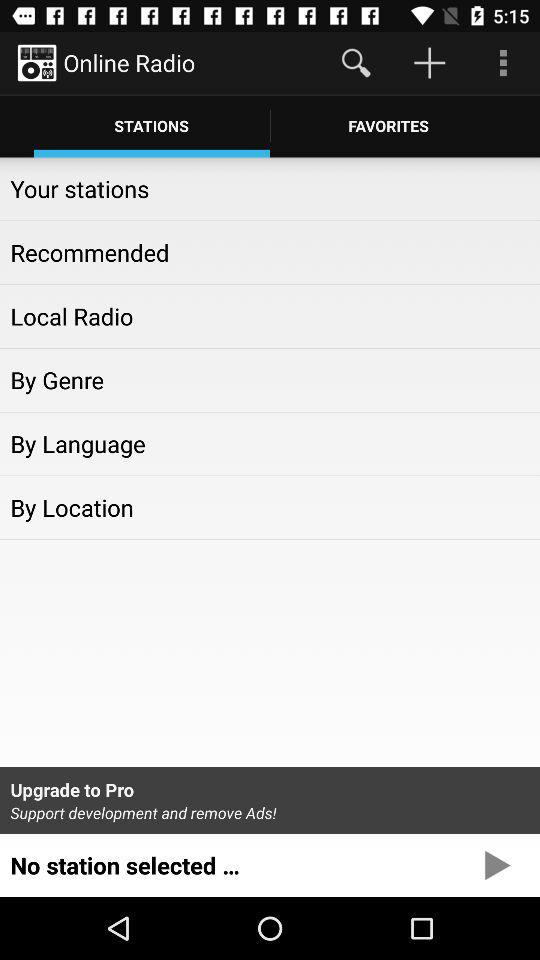What is the application name? The application name is "Online Radio". 